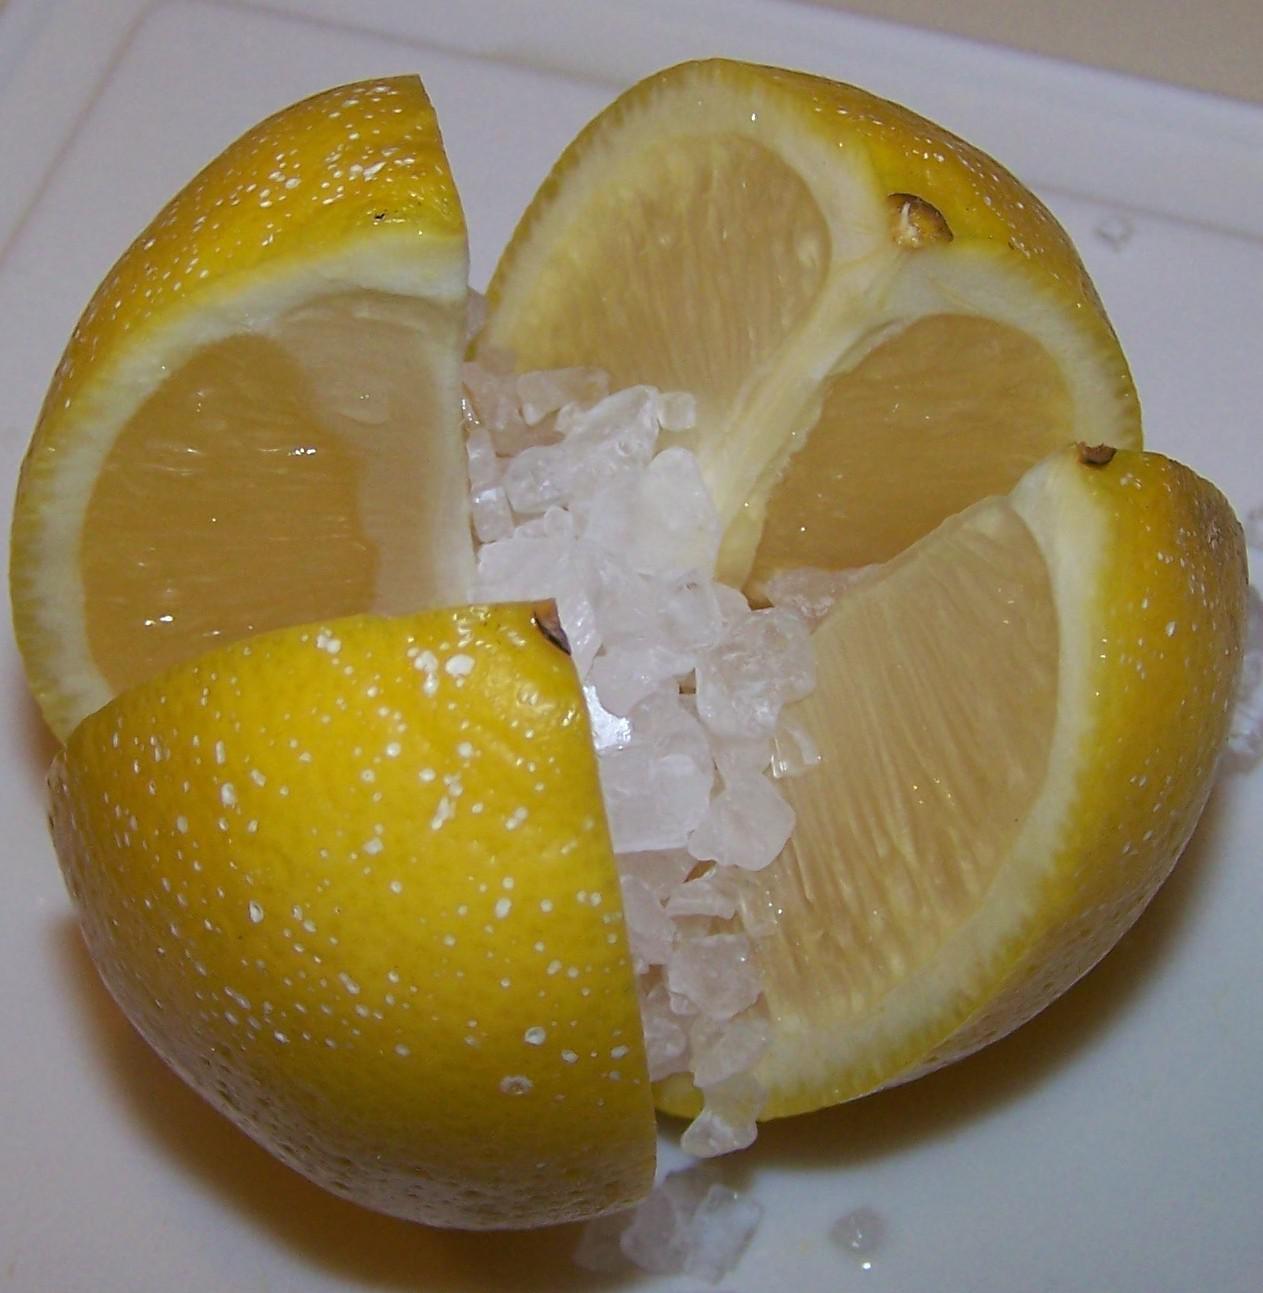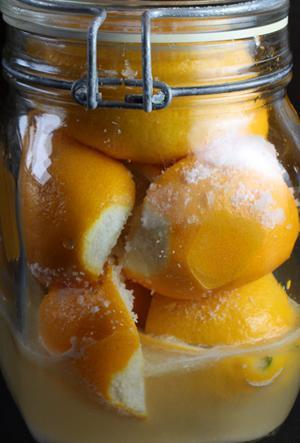The first image is the image on the left, the second image is the image on the right. For the images displayed, is the sentence "In at least one image there are a total of four lemon slices." factually correct? Answer yes or no. Yes. 